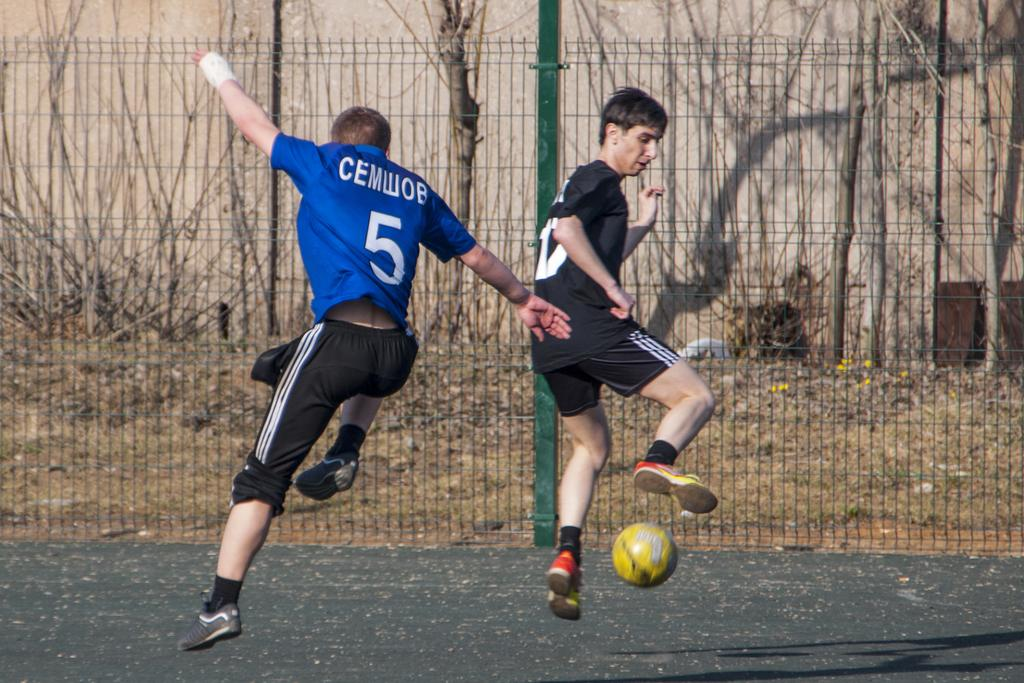<image>
Present a compact description of the photo's key features. a soccer player trying to get the ball in a blue jersey number 5 named CEMWOB 